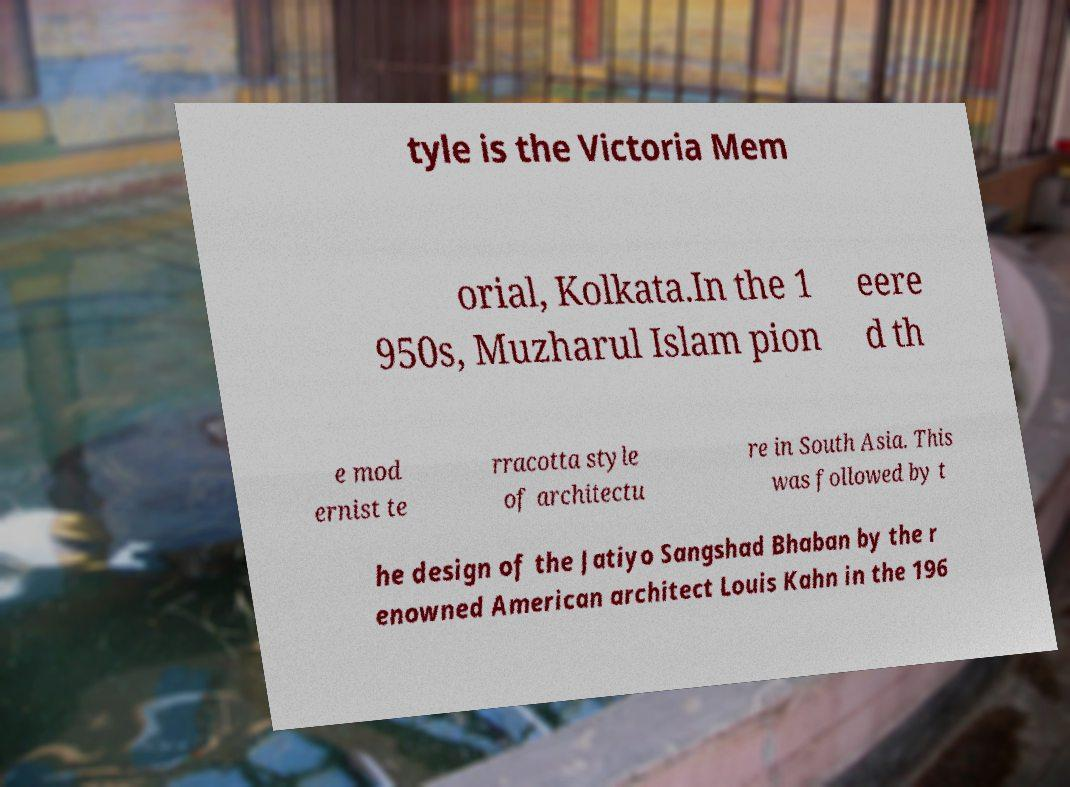Please read and relay the text visible in this image. What does it say? tyle is the Victoria Mem orial, Kolkata.In the 1 950s, Muzharul Islam pion eere d th e mod ernist te rracotta style of architectu re in South Asia. This was followed by t he design of the Jatiyo Sangshad Bhaban by the r enowned American architect Louis Kahn in the 196 